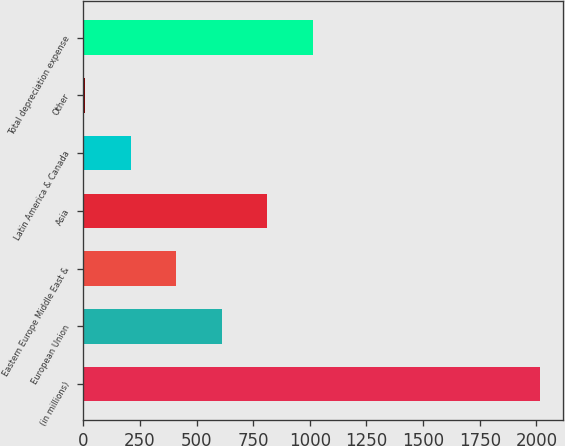Convert chart to OTSL. <chart><loc_0><loc_0><loc_500><loc_500><bar_chart><fcel>(in millions)<fcel>European Union<fcel>Eastern Europe Middle East &<fcel>Asia<fcel>Latin America & Canada<fcel>Other<fcel>Total depreciation expense<nl><fcel>2016<fcel>611.1<fcel>410.4<fcel>811.8<fcel>209.7<fcel>9<fcel>1012.5<nl></chart> 